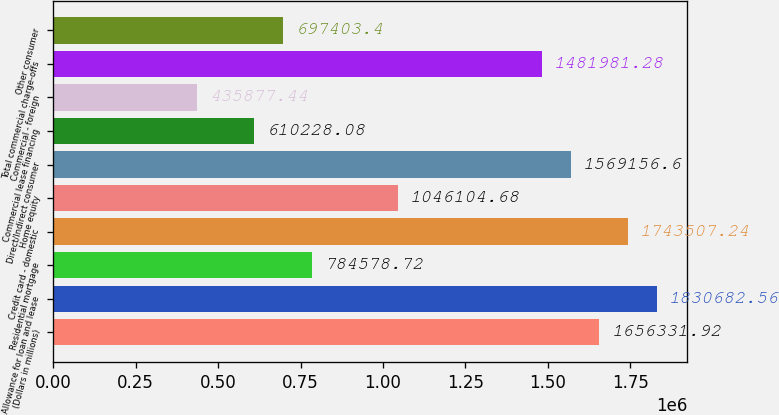Convert chart to OTSL. <chart><loc_0><loc_0><loc_500><loc_500><bar_chart><fcel>(Dollars in millions)<fcel>Allowance for loan and lease<fcel>Residential mortgage<fcel>Credit card - domestic<fcel>Home equity<fcel>Direct/Indirect consumer<fcel>Commercial lease financing<fcel>Commercial - foreign<fcel>Total commercial charge-offs<fcel>Other consumer<nl><fcel>1.65633e+06<fcel>1.83068e+06<fcel>784579<fcel>1.74351e+06<fcel>1.0461e+06<fcel>1.56916e+06<fcel>610228<fcel>435877<fcel>1.48198e+06<fcel>697403<nl></chart> 